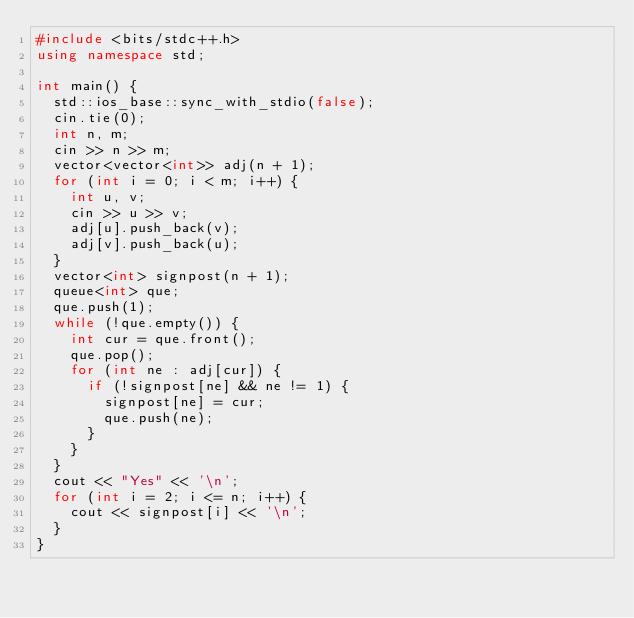<code> <loc_0><loc_0><loc_500><loc_500><_C++_>#include <bits/stdc++.h>
using namespace std;

int main() {
	std::ios_base::sync_with_stdio(false);
	cin.tie(0);
	int n, m;
	cin >> n >> m;
	vector<vector<int>> adj(n + 1);
	for (int i = 0; i < m; i++) {
		int u, v;
		cin >> u >> v;
		adj[u].push_back(v);
		adj[v].push_back(u);
	}
	vector<int> signpost(n + 1);
	queue<int> que;
	que.push(1);
	while (!que.empty()) {
		int cur = que.front();
		que.pop();
		for (int ne : adj[cur]) {
			if (!signpost[ne] && ne != 1) {
				signpost[ne] = cur;
				que.push(ne);
			}
		}
	}
	cout << "Yes" << '\n';
	for (int i = 2; i <= n; i++) {
		cout << signpost[i] << '\n';
	}
}

</code> 